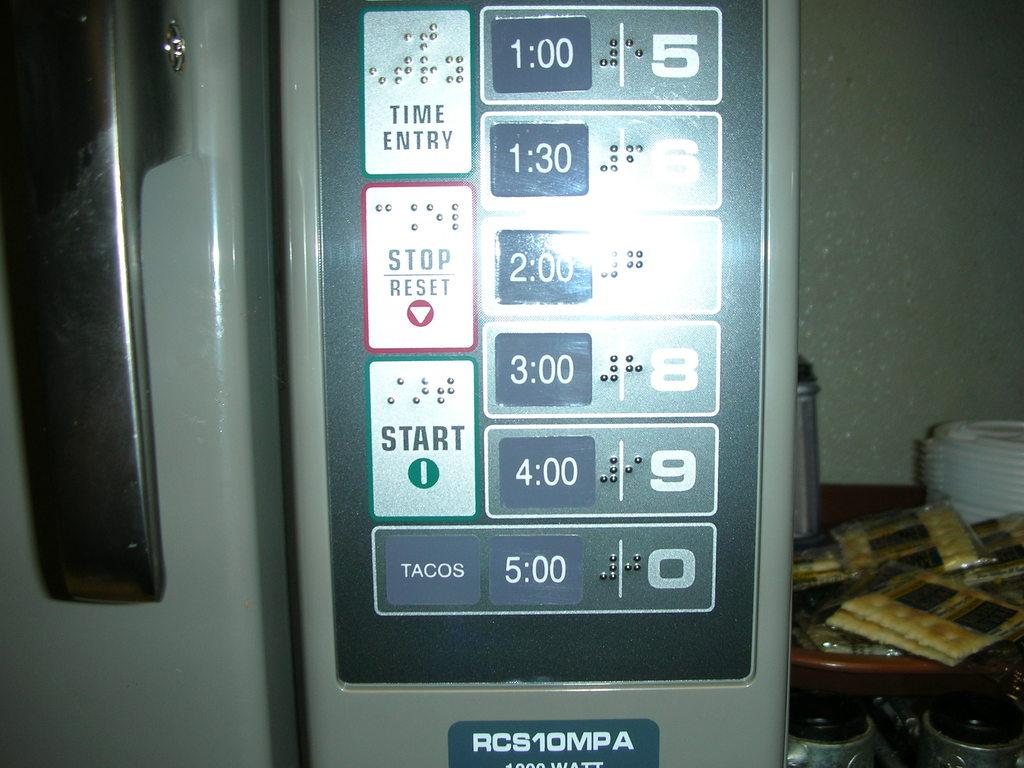<image>
Provide a brief description of the given image. A control pad has start, stop, and time entry key pads. 